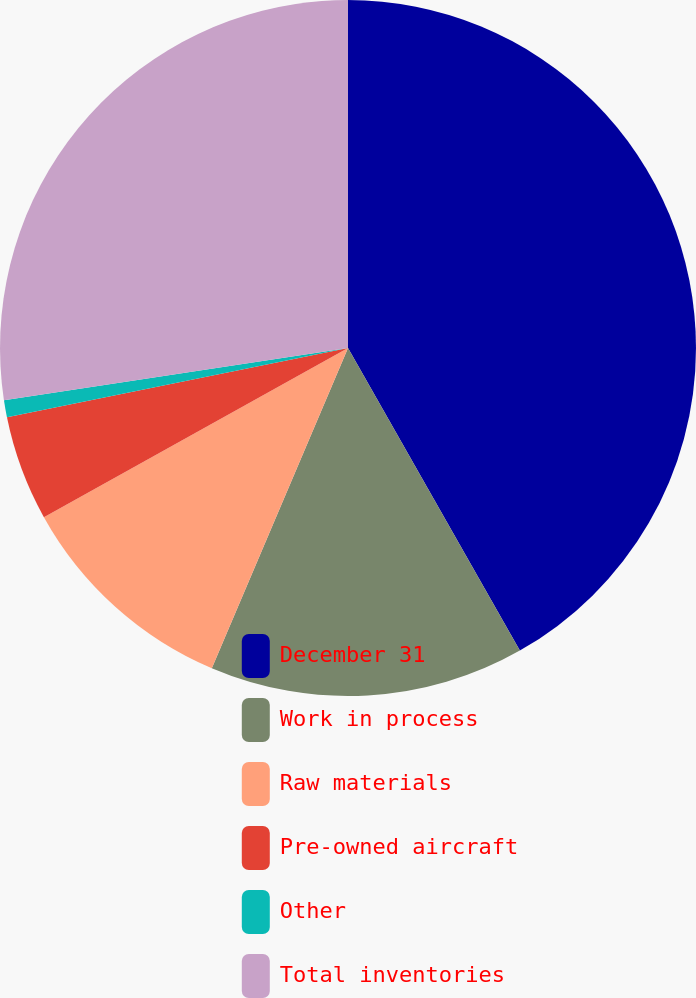Convert chart. <chart><loc_0><loc_0><loc_500><loc_500><pie_chart><fcel>December 31<fcel>Work in process<fcel>Raw materials<fcel>Pre-owned aircraft<fcel>Other<fcel>Total inventories<nl><fcel>41.78%<fcel>14.62%<fcel>10.52%<fcel>4.89%<fcel>0.79%<fcel>27.4%<nl></chart> 